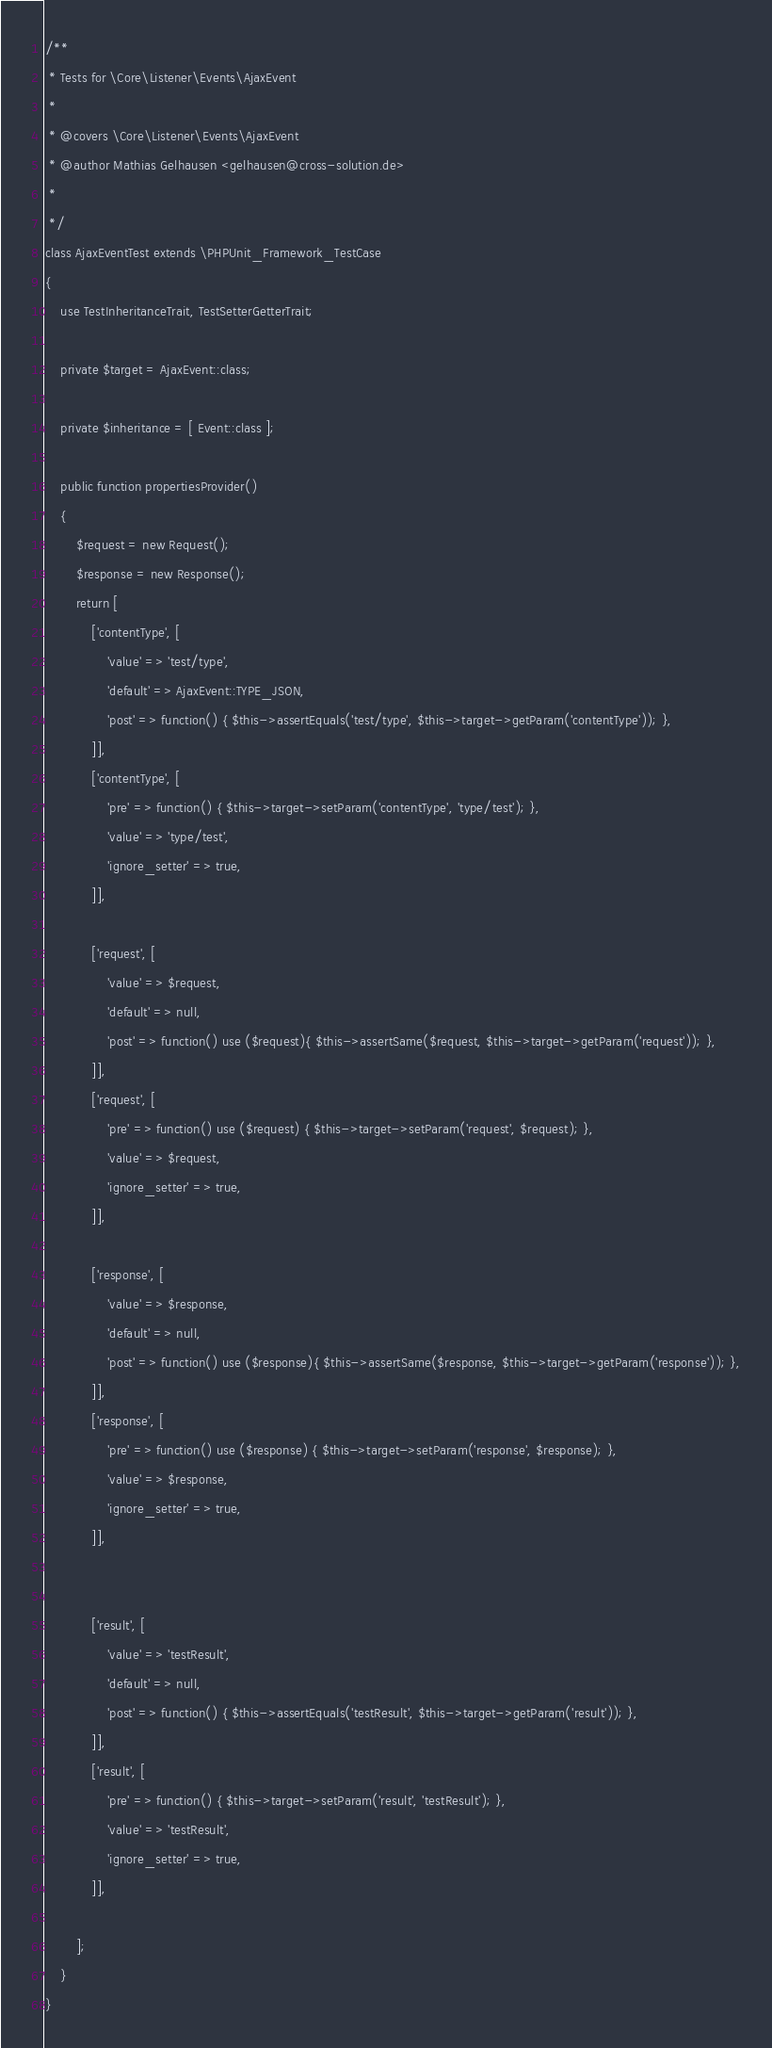<code> <loc_0><loc_0><loc_500><loc_500><_PHP_>/**
 * Tests for \Core\Listener\Events\AjaxEvent
 * 
 * @covers \Core\Listener\Events\AjaxEvent
 * @author Mathias Gelhausen <gelhausen@cross-solution.de>
 *  
 */
class AjaxEventTest extends \PHPUnit_Framework_TestCase
{
    use TestInheritanceTrait, TestSetterGetterTrait;

    private $target = AjaxEvent::class;

    private $inheritance = [ Event::class ];

    public function propertiesProvider()
    {
        $request = new Request();
        $response = new Response();
        return [
            ['contentType', [
                'value' => 'test/type',
                'default' => AjaxEvent::TYPE_JSON,
                'post' => function() { $this->assertEquals('test/type', $this->target->getParam('contentType')); },
            ]],
            ['contentType', [
                'pre' => function() { $this->target->setParam('contentType', 'type/test'); },
                'value' => 'type/test',
                'ignore_setter' => true,
            ]],

            ['request', [
                'value' => $request,
                'default' => null,
                'post' => function() use ($request){ $this->assertSame($request, $this->target->getParam('request')); },
            ]],
            ['request', [
                'pre' => function() use ($request) { $this->target->setParam('request', $request); },
                'value' => $request,
                'ignore_setter' => true,
            ]],

            ['response', [
                'value' => $response,
                'default' => null,
                'post' => function() use ($response){ $this->assertSame($response, $this->target->getParam('response')); },
            ]],
            ['response', [
                'pre' => function() use ($response) { $this->target->setParam('response', $response); },
                'value' => $response,
                'ignore_setter' => true,
            ]],


            ['result', [
                'value' => 'testResult',
                'default' => null,
                'post' => function() { $this->assertEquals('testResult', $this->target->getParam('result')); },
            ]],
            ['result', [
                'pre' => function() { $this->target->setParam('result', 'testResult'); },
                'value' => 'testResult',
                'ignore_setter' => true,
            ]],

        ];
    }
}</code> 